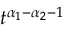<formula> <loc_0><loc_0><loc_500><loc_500>t ^ { \alpha _ { 1 } - \alpha _ { 2 } - 1 }</formula> 